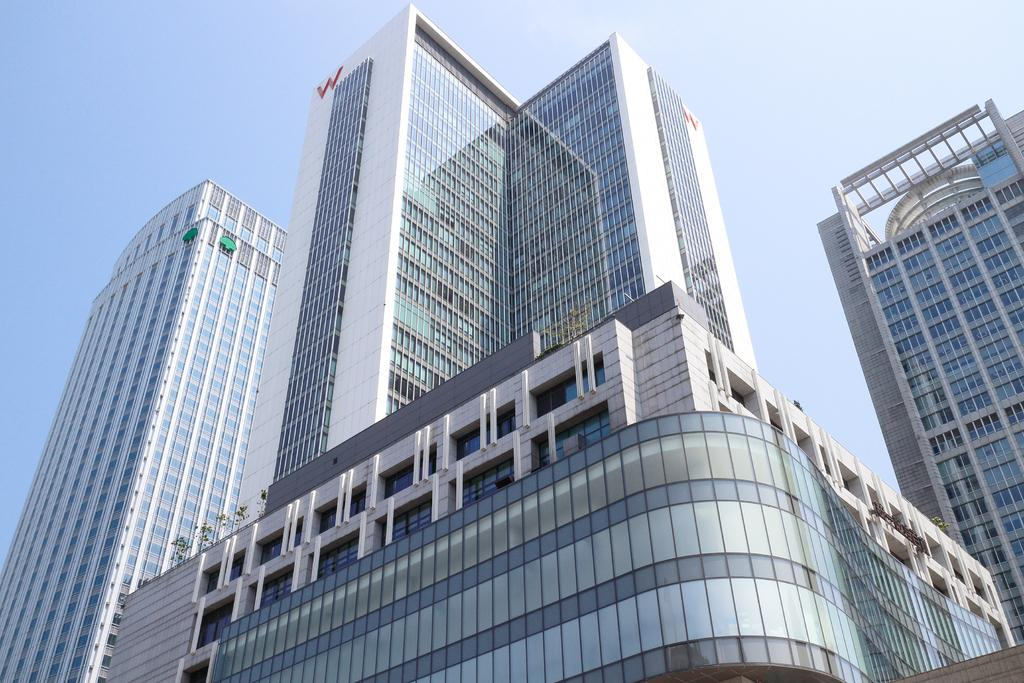What type of buildings are visible in the image? The buildings in the image have glass windows. What can be seen in the background of the image? The background of the image includes a blue sky. How many birds are flying in the town shown in the image? There are no birds or towns visible in the image; it only features buildings with glass windows and a blue sky in the background. 